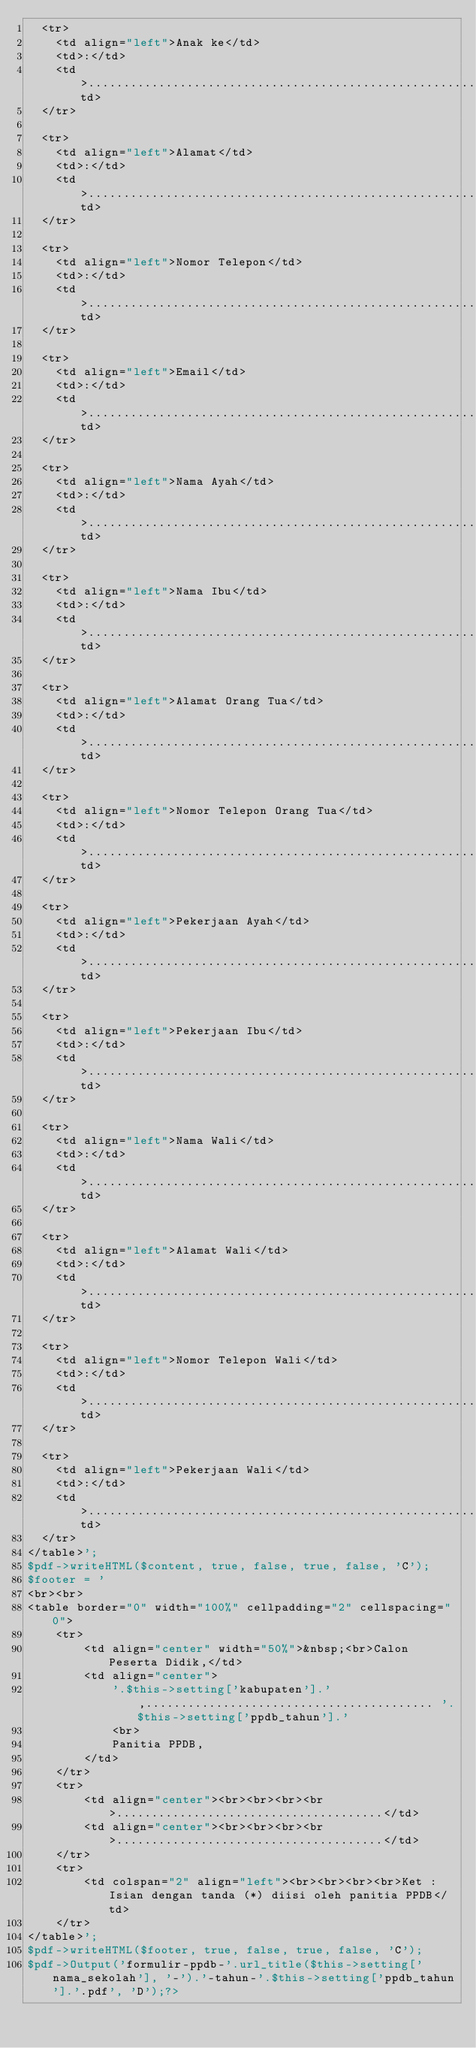<code> <loc_0><loc_0><loc_500><loc_500><_PHP_>  <tr>
    <td align="left">Anak ke</td>
    <td>:</td>
    <td>.............................................................................................</td>
  </tr>

  <tr>
    <td align="left">Alamat</td>
    <td>:</td>
    <td>.............................................................................................</td>
  </tr>

  <tr>
    <td align="left">Nomor Telepon</td>
    <td>:</td>
    <td>.............................................................................................</td>
  </tr>

  <tr>
    <td align="left">Email</td>
    <td>:</td>
    <td>.............................................................................................</td>
  </tr>

  <tr>
    <td align="left">Nama Ayah</td>
    <td>:</td>
    <td>.............................................................................................</td>
  </tr>

  <tr>
    <td align="left">Nama Ibu</td>
    <td>:</td>
    <td>.............................................................................................</td>
  </tr>

  <tr>
    <td align="left">Alamat Orang Tua</td>
    <td>:</td>
    <td>.............................................................................................</td>
  </tr>

  <tr>
    <td align="left">Nomor Telepon Orang Tua</td>
    <td>:</td>
    <td>.............................................................................................</td>
  </tr>

  <tr>
    <td align="left">Pekerjaan Ayah</td>
    <td>:</td>
    <td>.............................................................................................</td>
  </tr>

  <tr>
    <td align="left">Pekerjaan Ibu</td>
    <td>:</td>
    <td>.............................................................................................</td>
  </tr>

  <tr>
    <td align="left">Nama Wali</td>
    <td>:</td>
    <td>.............................................................................................</td>
  </tr>

  <tr>
    <td align="left">Alamat Wali</td>
    <td>:</td>
    <td>.............................................................................................</td>
  </tr>

  <tr>
    <td align="left">Nomor Telepon Wali</td>
    <td>:</td>
    <td>.............................................................................................</td>
  </tr>

  <tr>
    <td align="left">Pekerjaan Wali</td>
    <td>:</td>
    <td>.............................................................................................</td>
  </tr>
</table>';
$pdf->writeHTML($content, true, false, true, false, 'C');
$footer = '
<br><br>
<table border="0" width="100%" cellpadding="2" cellspacing="0">
    <tr>
        <td align="center" width="50%">&nbsp;<br>Calon Peserta Didik,</td>
        <td align="center">
            '.$this->setting['kabupaten'].',......................................... '.$this->setting['ppdb_tahun'].'
            <br>
            Panitia PPDB,
        </td>
    </tr>
    <tr>
        <td align="center"><br><br><br><br>......................................</td>
        <td align="center"><br><br><br><br>......................................</td>
    </tr>
    <tr>
        <td colspan="2" align="left"><br><br><br><br>Ket : Isian dengan tanda (*) diisi oleh panitia PPDB</td>
    </tr>
</table>';
$pdf->writeHTML($footer, true, false, true, false, 'C');
$pdf->Output('formulir-ppdb-'.url_title($this->setting['nama_sekolah'], '-').'-tahun-'.$this->setting['ppdb_tahun'].'.pdf', 'D');?></code> 